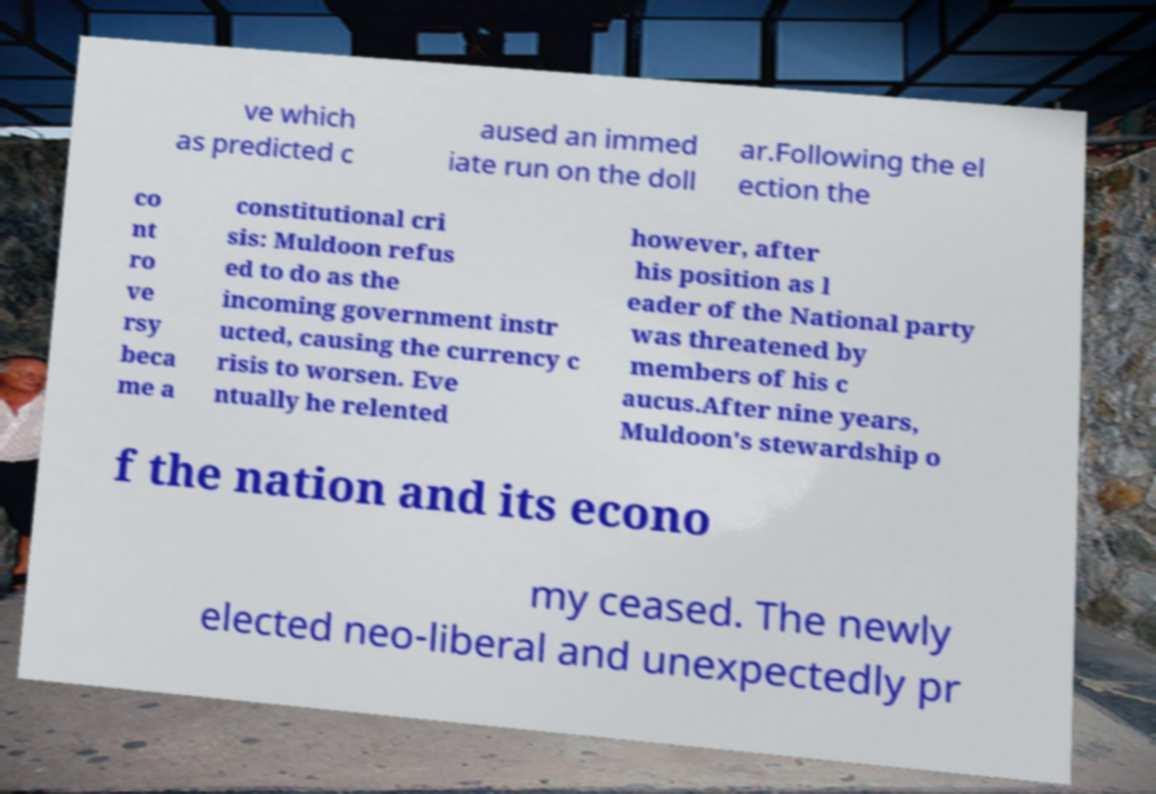What messages or text are displayed in this image? I need them in a readable, typed format. ve which as predicted c aused an immed iate run on the doll ar.Following the el ection the co nt ro ve rsy beca me a constitutional cri sis: Muldoon refus ed to do as the incoming government instr ucted, causing the currency c risis to worsen. Eve ntually he relented however, after his position as l eader of the National party was threatened by members of his c aucus.After nine years, Muldoon's stewardship o f the nation and its econo my ceased. The newly elected neo-liberal and unexpectedly pr 